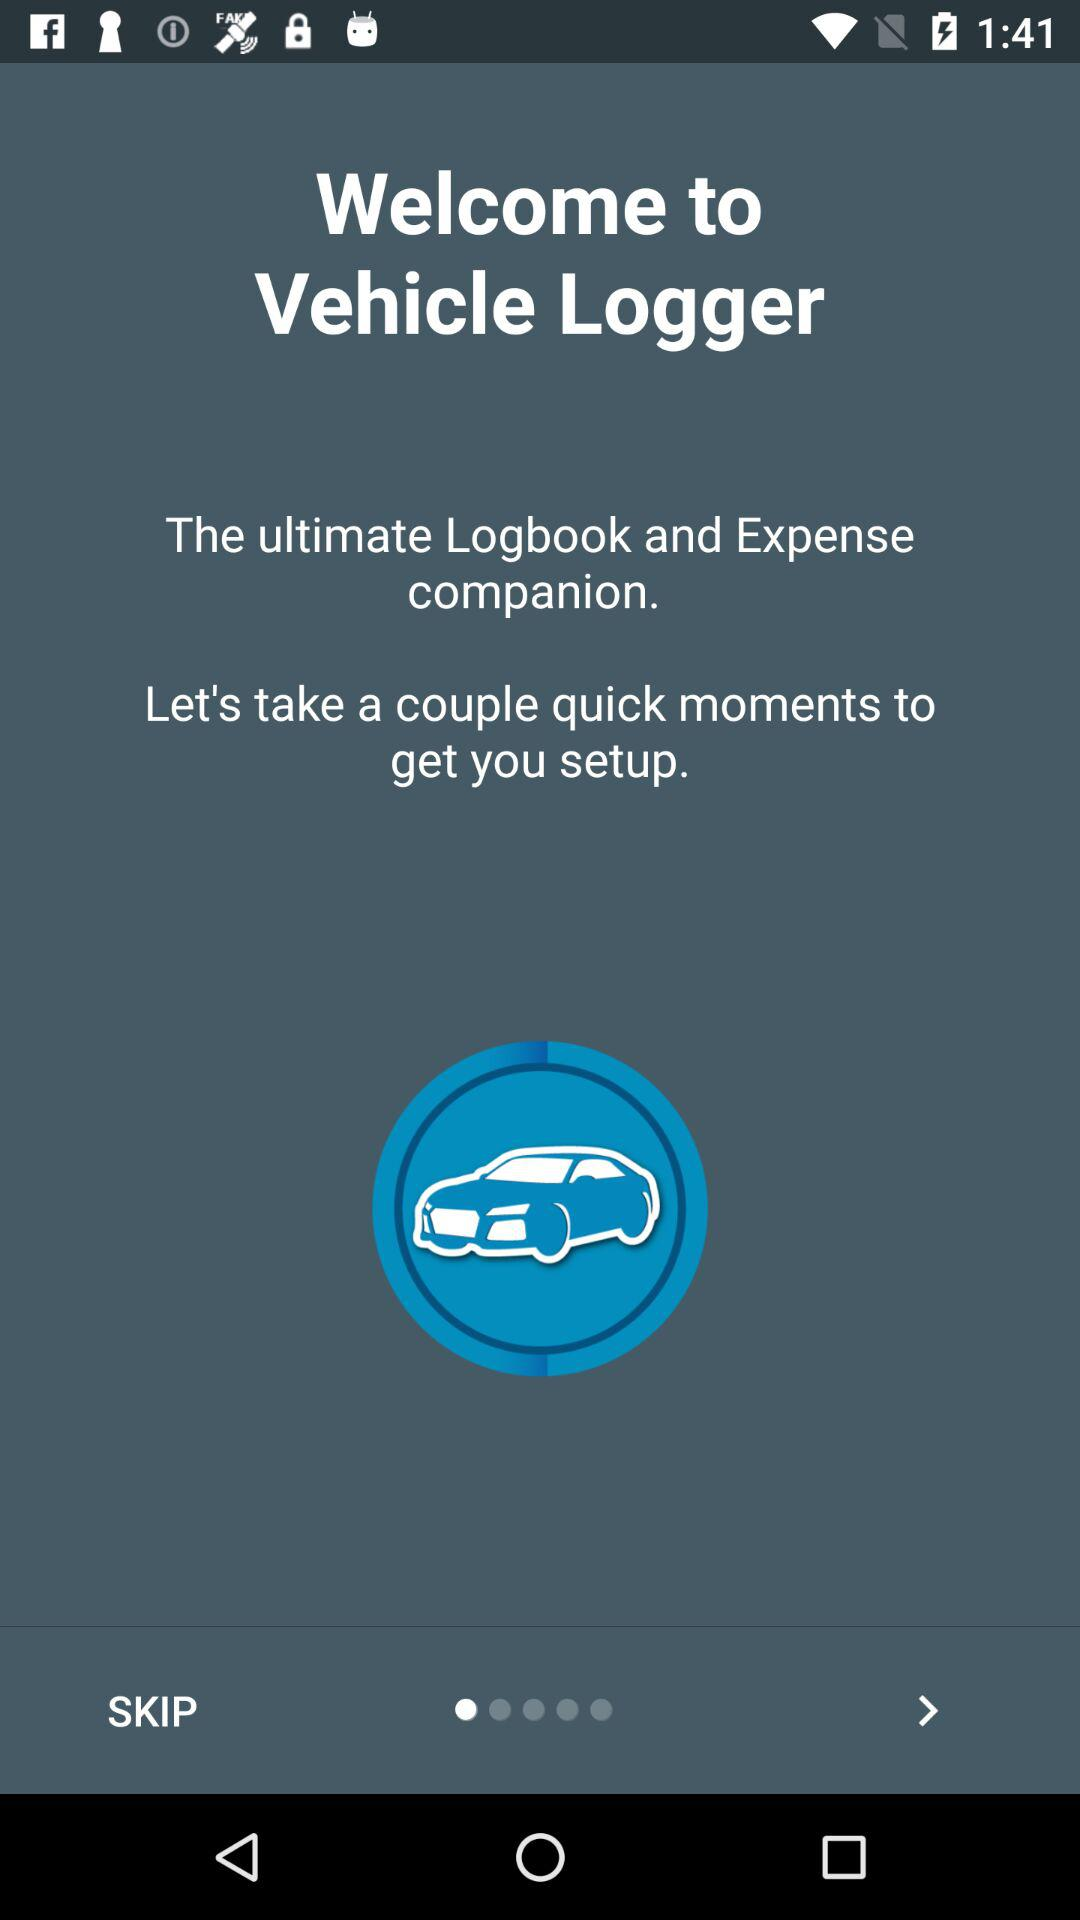What is the name of the application? The name of the application is "Vehicle Logger". 